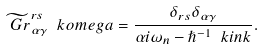Convert formula to latex. <formula><loc_0><loc_0><loc_500><loc_500>\widetilde { \ G r } ^ { r s } _ { \alpha \gamma } \ k o m e g a = \frac { \delta _ { r s } \delta _ { \alpha \gamma } } { \alpha i \omega _ { n } - \hslash ^ { - 1 } \ k i n k } .</formula> 